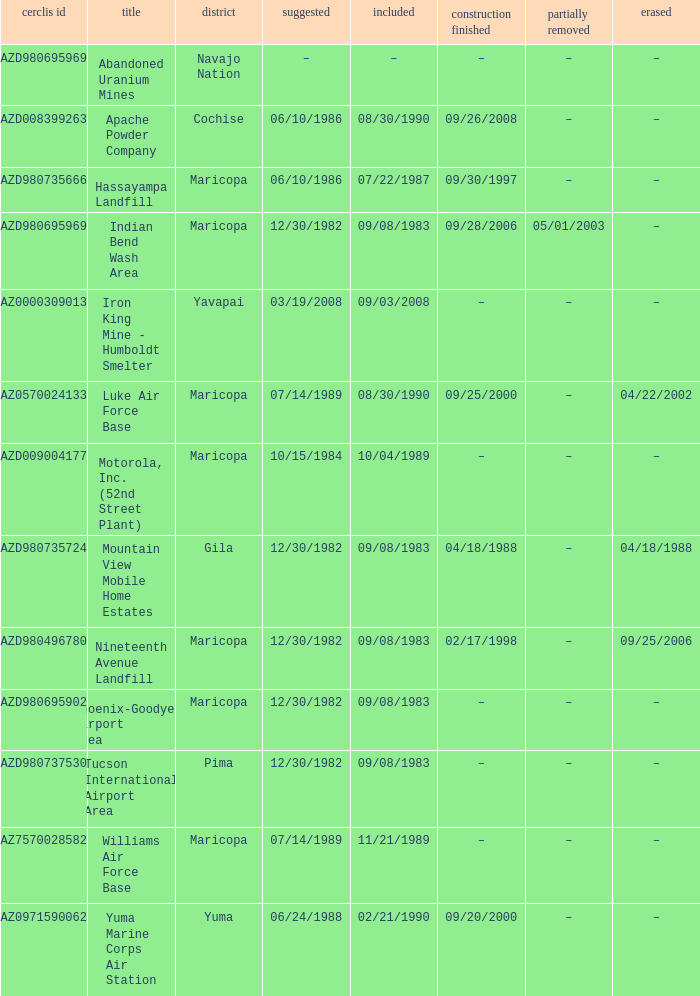When was the site listed when the county is cochise? 08/30/1990. 